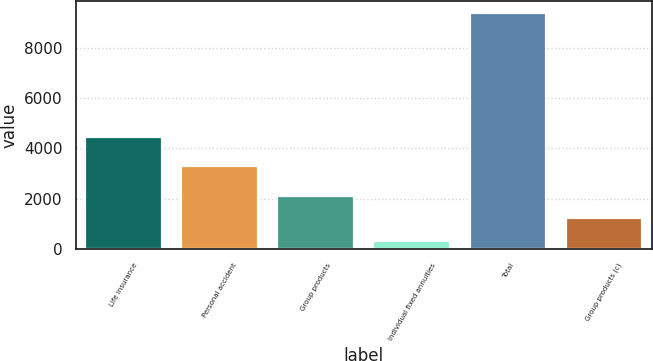<chart> <loc_0><loc_0><loc_500><loc_500><bar_chart><fcel>Life insurance<fcel>Personal accident<fcel>Group products<fcel>Individual fixed annuities<fcel>Total<fcel>Group products (c)<nl><fcel>4469<fcel>3307<fcel>2126.6<fcel>312<fcel>9385<fcel>1219.3<nl></chart> 